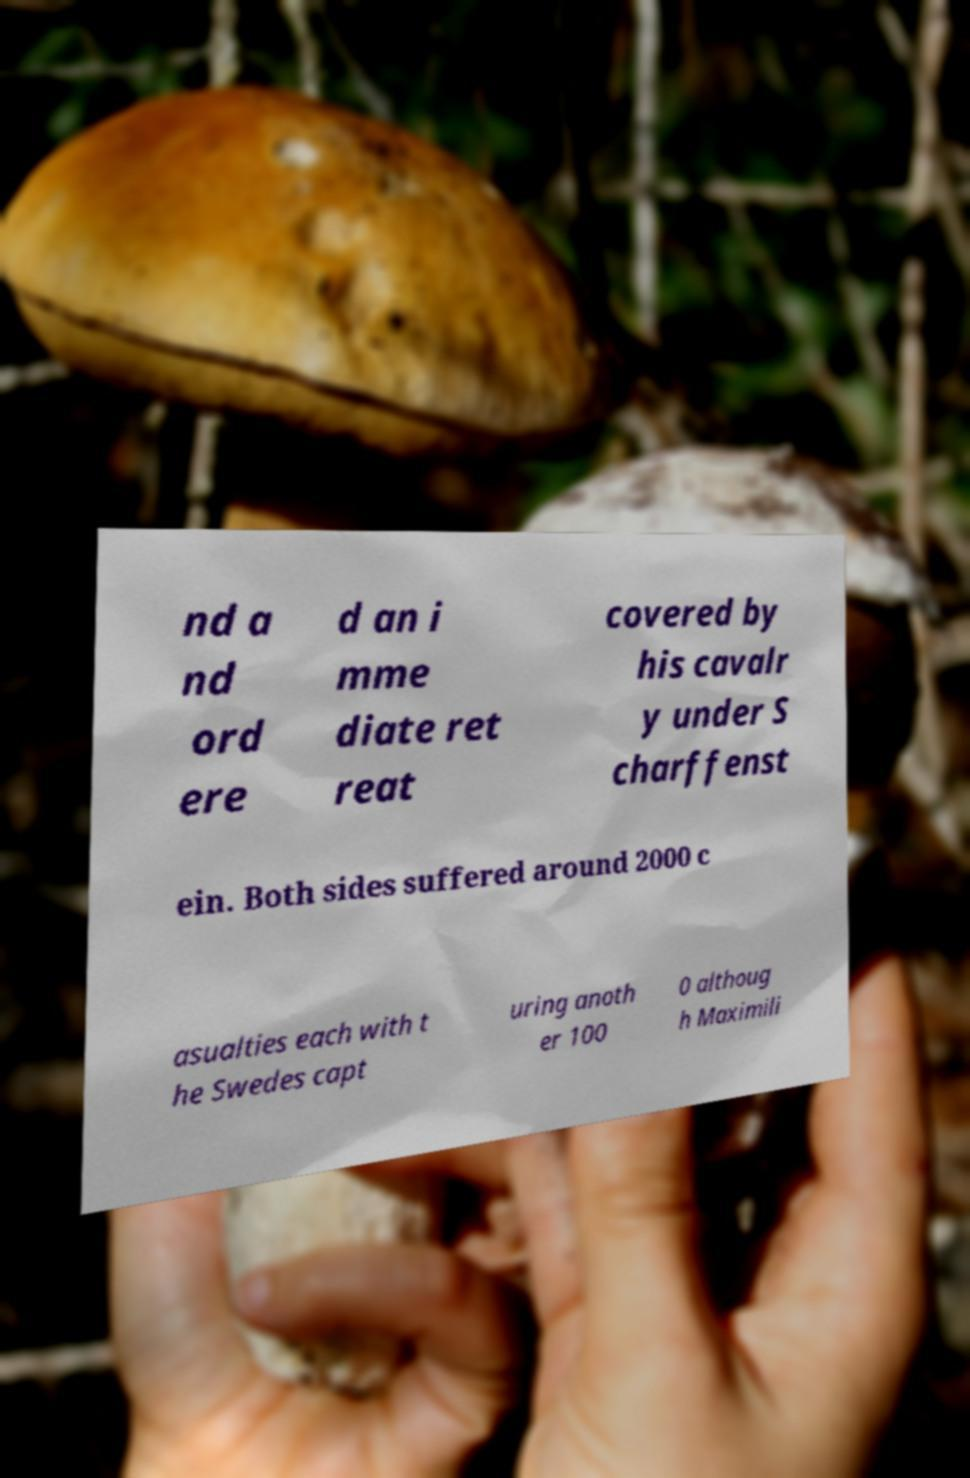Can you accurately transcribe the text from the provided image for me? nd a nd ord ere d an i mme diate ret reat covered by his cavalr y under S charffenst ein. Both sides suffered around 2000 c asualties each with t he Swedes capt uring anoth er 100 0 althoug h Maximili 